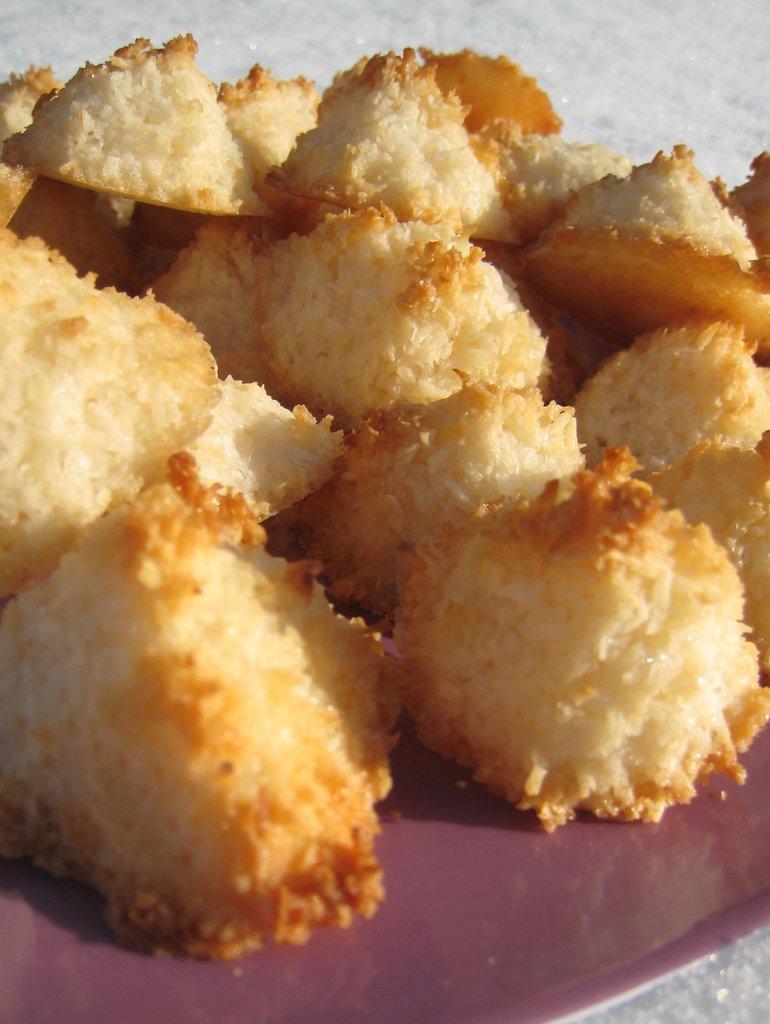Describe this image in one or two sentences. In the center of the image we can see a food item is present on the plate. 